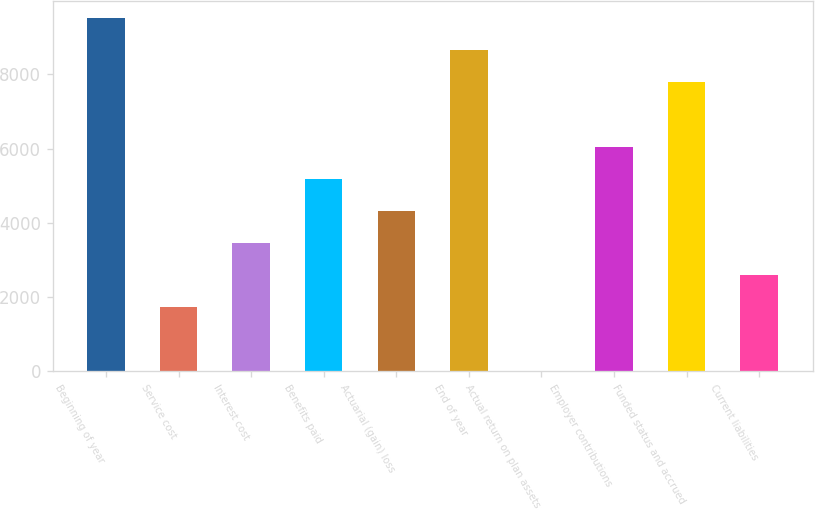Convert chart. <chart><loc_0><loc_0><loc_500><loc_500><bar_chart><fcel>Beginning of year<fcel>Service cost<fcel>Interest cost<fcel>Benefits paid<fcel>Actuarial (gain) loss<fcel>End of year<fcel>Actual return on plan assets<fcel>Employer contributions<fcel>Funded status and accrued<fcel>Current liabilities<nl><fcel>9510.4<fcel>1739.8<fcel>3466.6<fcel>5193.4<fcel>4330<fcel>8647<fcel>13<fcel>6056.8<fcel>7783.6<fcel>2603.2<nl></chart> 